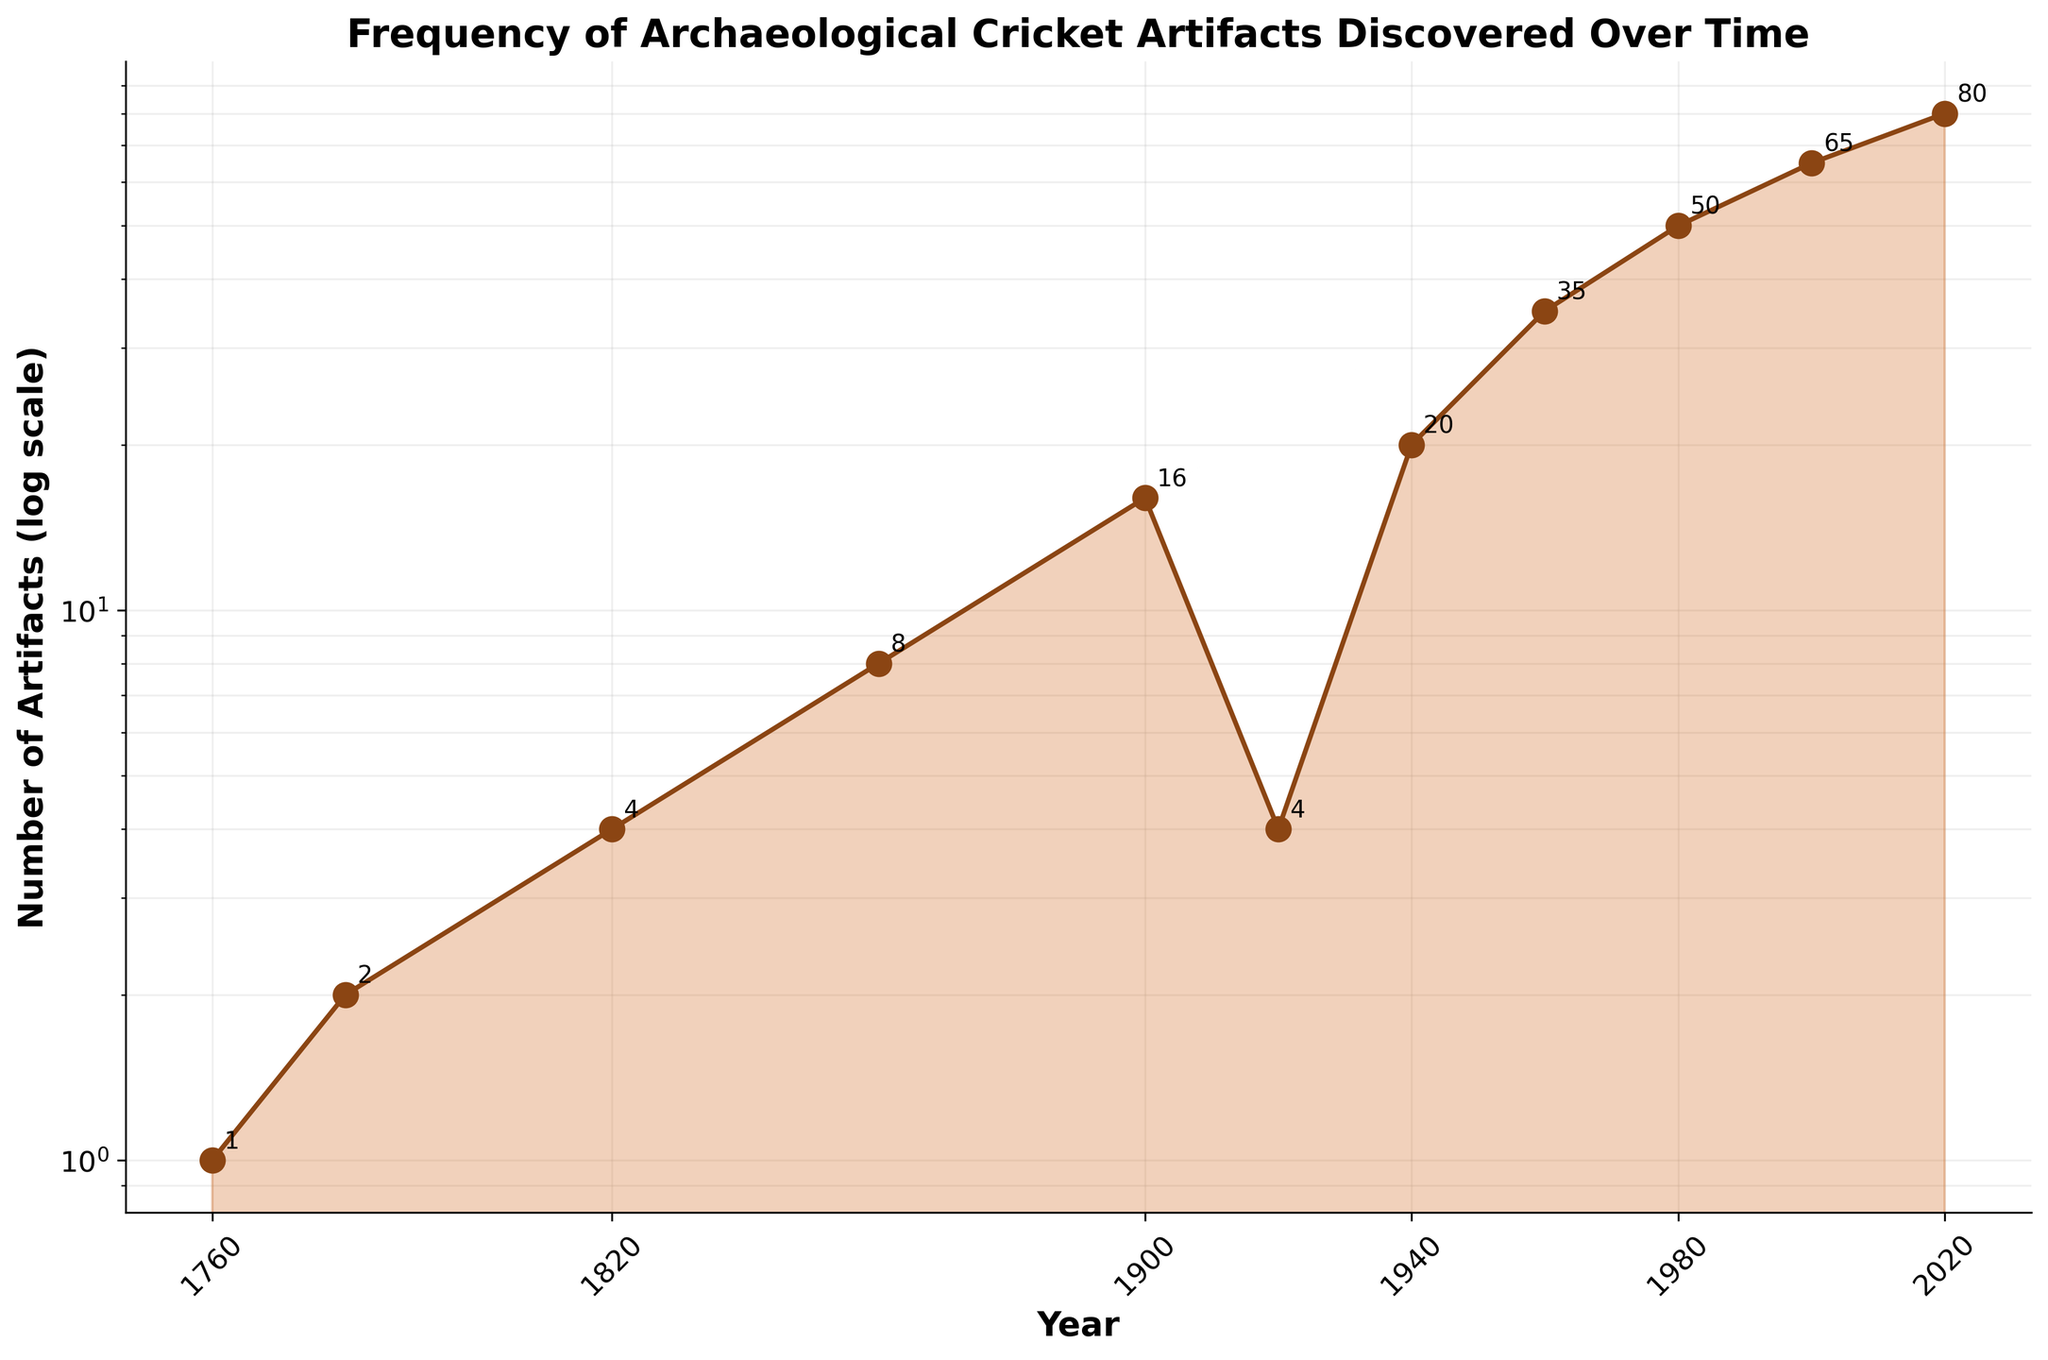What is the title of the plot? The title is located at the top of the plot; reading it directly provides the necessary information.
Answer: Frequency of Archaeological Cricket Artifacts Discovered Over Time How many data points are plotted? By counting the individual markers on the plot, we can determine the total number of data points.
Answer: 11 What is the value of the number of artifacts discovered in the year 1900? Locate the point corresponding to the year 1900 and read the number next to the marker.
Answer: 16 In which year were the fewest cricket artifacts discovered, according to the plot? By observing the y-axis values corresponding to each year, we can identify the point with the lowest value.
Answer: 1760 What is the overall trend in the number of artifacts discovered from 1760 to 2020? By observing the plot, we can identify that the general trend is upwards with some fluctuations.
Answer: Increasing What is the average number of artifacts discovered in the 20th century (1900-1999)? Sum the values for the years 1900, 1920, 1940, 1960, and 1980, then divide by the number of data points. Calculation: (16 + 4 + 20 + 35 + 50) / 5
Answer: 25 Which year saw the largest increase in artifacts discovered compared to the previous data point? By comparing the difference in the number of artifacts between consecutive years, we can determine the year with the largest increase.
Answer: 1960 How many artifacts were discovered in total from 1920 to 2020? Sum all the number of artifacts discovered for the years 1920, 1940, 1960, 1980, 2000, and 2020. Calculation: 4 + 20 + 35 + 50 + 65 + 80
Answer: 254 Between which consecutive years did the number of artifacts decrease? By comparing each pair of consecutive data points, we can identify when the number of artifacts decreased.
Answer: 1900 to 1920 